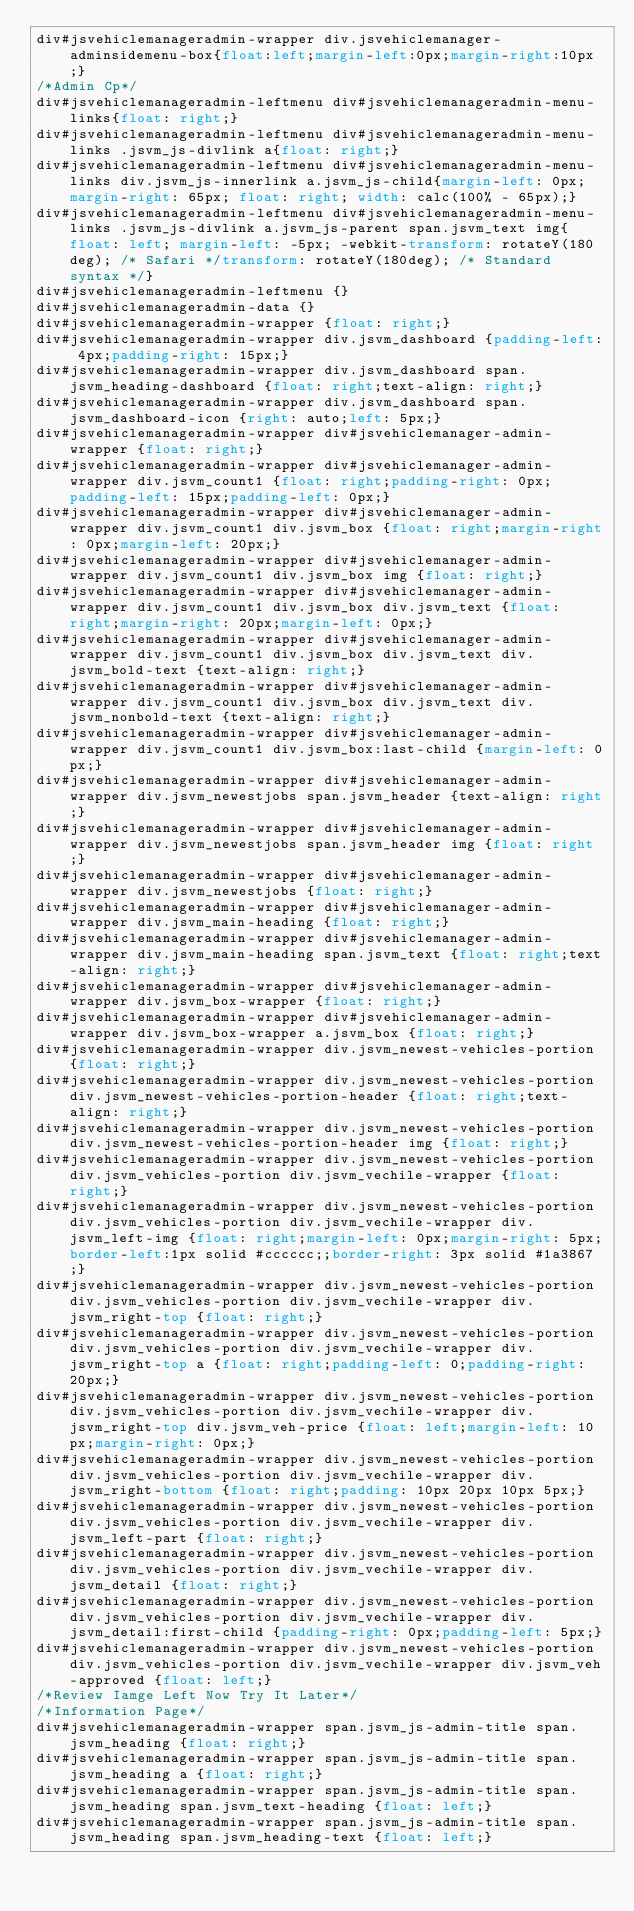<code> <loc_0><loc_0><loc_500><loc_500><_CSS_>div#jsvehiclemanageradmin-wrapper div.jsvehiclemanager-adminsidemenu-box{float:left;margin-left:0px;margin-right:10px;}
/*Admin Cp*/
div#jsvehiclemanageradmin-leftmenu div#jsvehiclemanageradmin-menu-links{float: right;}
div#jsvehiclemanageradmin-leftmenu div#jsvehiclemanageradmin-menu-links .jsvm_js-divlink a{float: right;}
div#jsvehiclemanageradmin-leftmenu div#jsvehiclemanageradmin-menu-links div.jsvm_js-innerlink a.jsvm_js-child{margin-left: 0px; margin-right: 65px; float: right; width: calc(100% - 65px);}
div#jsvehiclemanageradmin-leftmenu div#jsvehiclemanageradmin-menu-links .jsvm_js-divlink a.jsvm_js-parent span.jsvm_text img{float: left; margin-left: -5px; -webkit-transform: rotateY(180deg); /* Safari */transform: rotateY(180deg); /* Standard syntax */}
div#jsvehiclemanageradmin-leftmenu {}
div#jsvehiclemanageradmin-data {}
div#jsvehiclemanageradmin-wrapper {float: right;}
div#jsvehiclemanageradmin-wrapper div.jsvm_dashboard {padding-left: 4px;padding-right: 15px;}
div#jsvehiclemanageradmin-wrapper div.jsvm_dashboard span.jsvm_heading-dashboard {float: right;text-align: right;}
div#jsvehiclemanageradmin-wrapper div.jsvm_dashboard span.jsvm_dashboard-icon {right: auto;left: 5px;}
div#jsvehiclemanageradmin-wrapper div#jsvehiclemanager-admin-wrapper {float: right;}
div#jsvehiclemanageradmin-wrapper div#jsvehiclemanager-admin-wrapper div.jsvm_count1 {float: right;padding-right: 0px;padding-left: 15px;padding-left: 0px;}
div#jsvehiclemanageradmin-wrapper div#jsvehiclemanager-admin-wrapper div.jsvm_count1 div.jsvm_box {float: right;margin-right: 0px;margin-left: 20px;}
div#jsvehiclemanageradmin-wrapper div#jsvehiclemanager-admin-wrapper div.jsvm_count1 div.jsvm_box img {float: right;}
div#jsvehiclemanageradmin-wrapper div#jsvehiclemanager-admin-wrapper div.jsvm_count1 div.jsvm_box div.jsvm_text {float: right;margin-right: 20px;margin-left: 0px;}
div#jsvehiclemanageradmin-wrapper div#jsvehiclemanager-admin-wrapper div.jsvm_count1 div.jsvm_box div.jsvm_text div.jsvm_bold-text {text-align: right;}
div#jsvehiclemanageradmin-wrapper div#jsvehiclemanager-admin-wrapper div.jsvm_count1 div.jsvm_box div.jsvm_text div.jsvm_nonbold-text {text-align: right;}
div#jsvehiclemanageradmin-wrapper div#jsvehiclemanager-admin-wrapper div.jsvm_count1 div.jsvm_box:last-child {margin-left: 0px;} 
div#jsvehiclemanageradmin-wrapper div#jsvehiclemanager-admin-wrapper div.jsvm_newestjobs span.jsvm_header {text-align: right;}
div#jsvehiclemanageradmin-wrapper div#jsvehiclemanager-admin-wrapper div.jsvm_newestjobs span.jsvm_header img {float: right;}
div#jsvehiclemanageradmin-wrapper div#jsvehiclemanager-admin-wrapper div.jsvm_newestjobs {float: right;}
div#jsvehiclemanageradmin-wrapper div#jsvehiclemanager-admin-wrapper div.jsvm_main-heading {float: right;}
div#jsvehiclemanageradmin-wrapper div#jsvehiclemanager-admin-wrapper div.jsvm_main-heading span.jsvm_text {float: right;text-align: right;}
div#jsvehiclemanageradmin-wrapper div#jsvehiclemanager-admin-wrapper div.jsvm_box-wrapper {float: right;}
div#jsvehiclemanageradmin-wrapper div#jsvehiclemanager-admin-wrapper div.jsvm_box-wrapper a.jsvm_box {float: right;}
div#jsvehiclemanageradmin-wrapper div.jsvm_newest-vehicles-portion {float: right;}
div#jsvehiclemanageradmin-wrapper div.jsvm_newest-vehicles-portion div.jsvm_newest-vehicles-portion-header {float: right;text-align: right;}
div#jsvehiclemanageradmin-wrapper div.jsvm_newest-vehicles-portion div.jsvm_newest-vehicles-portion-header img {float: right;}
div#jsvehiclemanageradmin-wrapper div.jsvm_newest-vehicles-portion div.jsvm_vehicles-portion div.jsvm_vechile-wrapper {float: right;}
div#jsvehiclemanageradmin-wrapper div.jsvm_newest-vehicles-portion div.jsvm_vehicles-portion div.jsvm_vechile-wrapper div.jsvm_left-img {float: right;margin-left: 0px;margin-right: 5px;border-left:1px solid #cccccc;;border-right: 3px solid #1a3867;}
div#jsvehiclemanageradmin-wrapper div.jsvm_newest-vehicles-portion div.jsvm_vehicles-portion div.jsvm_vechile-wrapper div.jsvm_right-top {float: right;}
div#jsvehiclemanageradmin-wrapper div.jsvm_newest-vehicles-portion div.jsvm_vehicles-portion div.jsvm_vechile-wrapper div.jsvm_right-top a {float: right;padding-left: 0;padding-right: 20px;}
div#jsvehiclemanageradmin-wrapper div.jsvm_newest-vehicles-portion div.jsvm_vehicles-portion div.jsvm_vechile-wrapper div.jsvm_right-top div.jsvm_veh-price {float: left;margin-left: 10px;margin-right: 0px;}
div#jsvehiclemanageradmin-wrapper div.jsvm_newest-vehicles-portion div.jsvm_vehicles-portion div.jsvm_vechile-wrapper div.jsvm_right-bottom {float: right;padding: 10px 20px 10px 5px;}
div#jsvehiclemanageradmin-wrapper div.jsvm_newest-vehicles-portion div.jsvm_vehicles-portion div.jsvm_vechile-wrapper div.jsvm_left-part {float: right;}
div#jsvehiclemanageradmin-wrapper div.jsvm_newest-vehicles-portion div.jsvm_vehicles-portion div.jsvm_vechile-wrapper div.jsvm_detail {float: right;}
div#jsvehiclemanageradmin-wrapper div.jsvm_newest-vehicles-portion div.jsvm_vehicles-portion div.jsvm_vechile-wrapper div.jsvm_detail:first-child {padding-right: 0px;padding-left: 5px;}
div#jsvehiclemanageradmin-wrapper div.jsvm_newest-vehicles-portion div.jsvm_vehicles-portion div.jsvm_vechile-wrapper div.jsvm_veh-approved {float: left;}
/*Review Iamge Left Now Try It Later*/
/*Information Page*/
div#jsvehiclemanageradmin-wrapper span.jsvm_js-admin-title span.jsvm_heading {float: right;}
div#jsvehiclemanageradmin-wrapper span.jsvm_js-admin-title span.jsvm_heading a {float: right;}
div#jsvehiclemanageradmin-wrapper span.jsvm_js-admin-title span.jsvm_heading span.jsvm_text-heading {float: left;}
div#jsvehiclemanageradmin-wrapper span.jsvm_js-admin-title span.jsvm_heading span.jsvm_heading-text {float: left;}</code> 